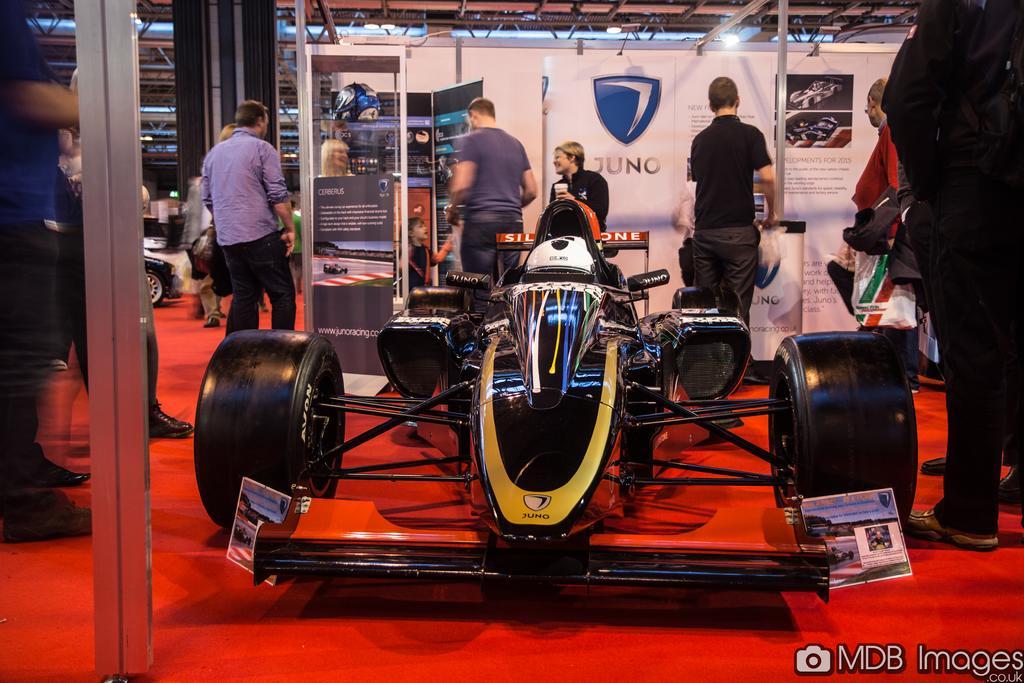Could you give a brief overview of what you see in this image? In this image, we can see a group of people and vehicle. Here we can see a vehicle wheel, rods, banners, board and light. Right side bottom corner, we can see a watermark in the image. 